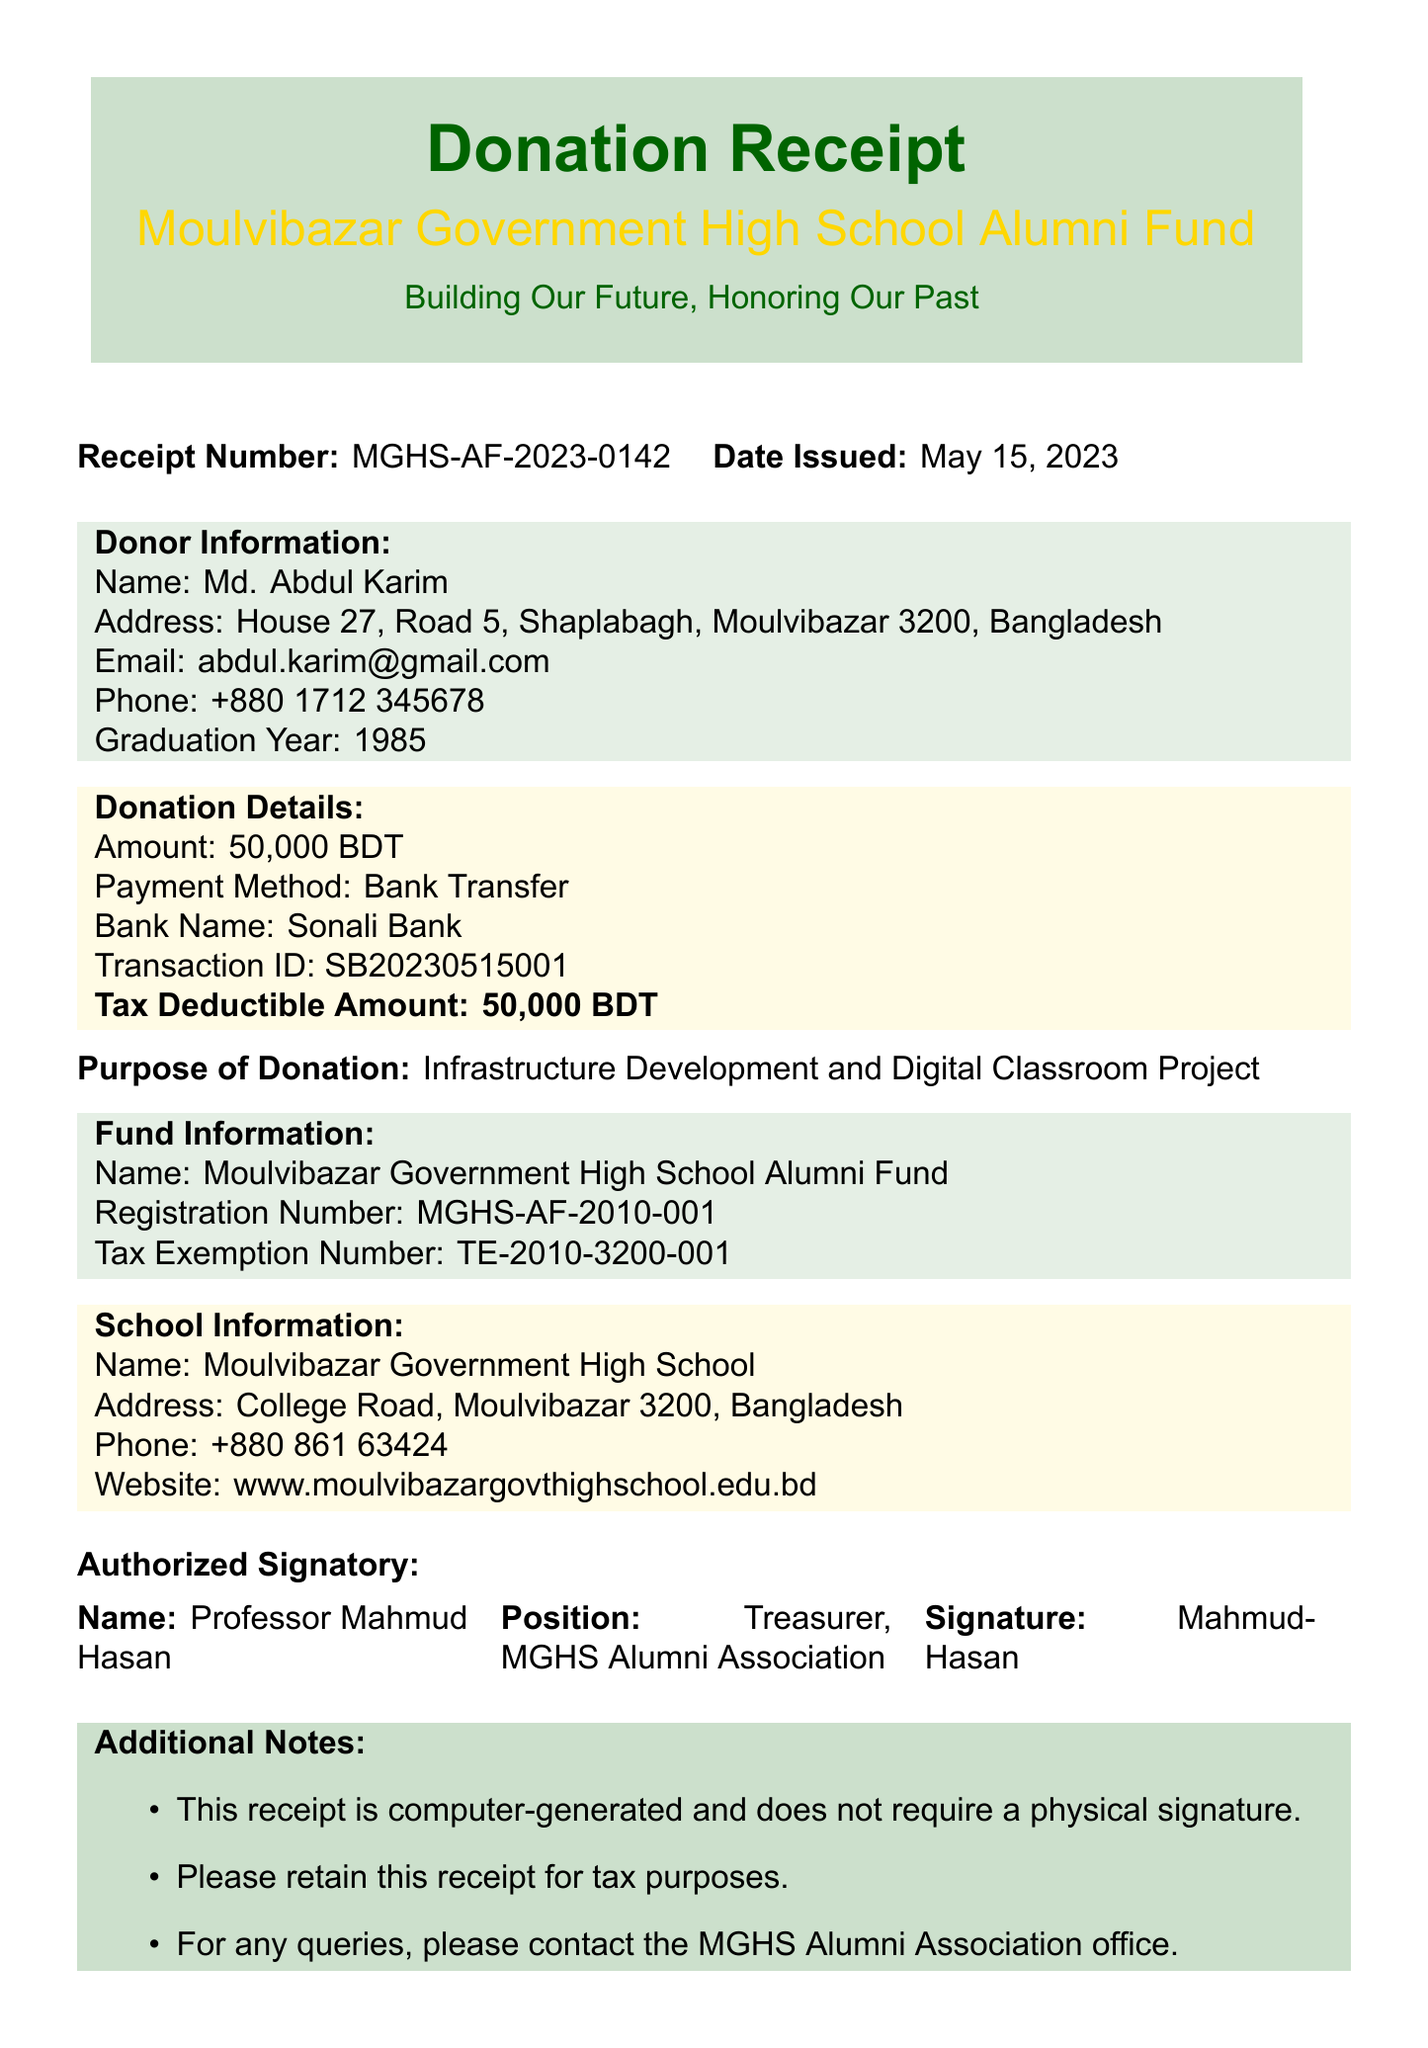What is the receipt number? The receipt number is clearly stated in the document for identification, which is "MGHS-AF-2023-0142".
Answer: MGHS-AF-2023-0142 Who is the donor? The document lists the donor's name for clarity, which is "Md. Abdul Karim".
Answer: Md. Abdul Karim What is the donation amount? The document specifies the total donation amount, which is "50000 BDT".
Answer: 50000 BDT What is the purpose of the donation? The document clearly states the purpose of the donation, which is for "Infrastructure Development and Digital Classroom Project".
Answer: Infrastructure Development and Digital Classroom Project What is the tax deductible amount? The tax deductible amount is mentioned in the donation details to inform the donor, which is "50000 BDT".
Answer: 50000 BDT What method was used for payment? The payment method is provided to indicate how the donation was made, which is "Bank Transfer".
Answer: Bank Transfer Who signed the receipt? The authorized signatory is listed in the document, and their name is "Professor Mahmud Hasan".
Answer: Professor Mahmud Hasan What is the bank name connected to the donation? The document specifies the bank used for the transaction, which is "Sonali Bank".
Answer: Sonali Bank 